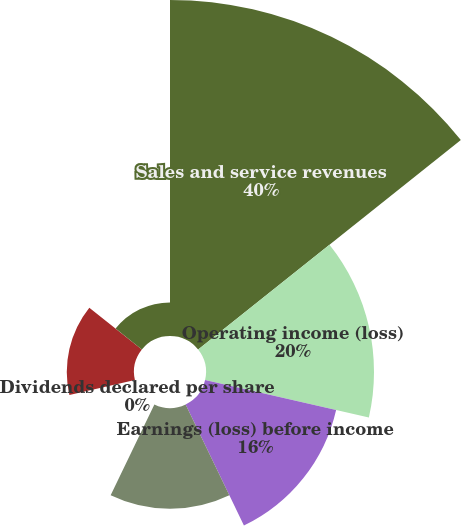Convert chart. <chart><loc_0><loc_0><loc_500><loc_500><pie_chart><fcel>Sales and service revenues<fcel>Operating income (loss)<fcel>Earnings (loss) before income<fcel>Net earnings (loss)<fcel>Dividends declared per share<fcel>Basic earnings (loss) per<fcel>Diluted earnings (loss) per<nl><fcel>40.0%<fcel>20.0%<fcel>16.0%<fcel>12.0%<fcel>0.0%<fcel>8.0%<fcel>4.0%<nl></chart> 